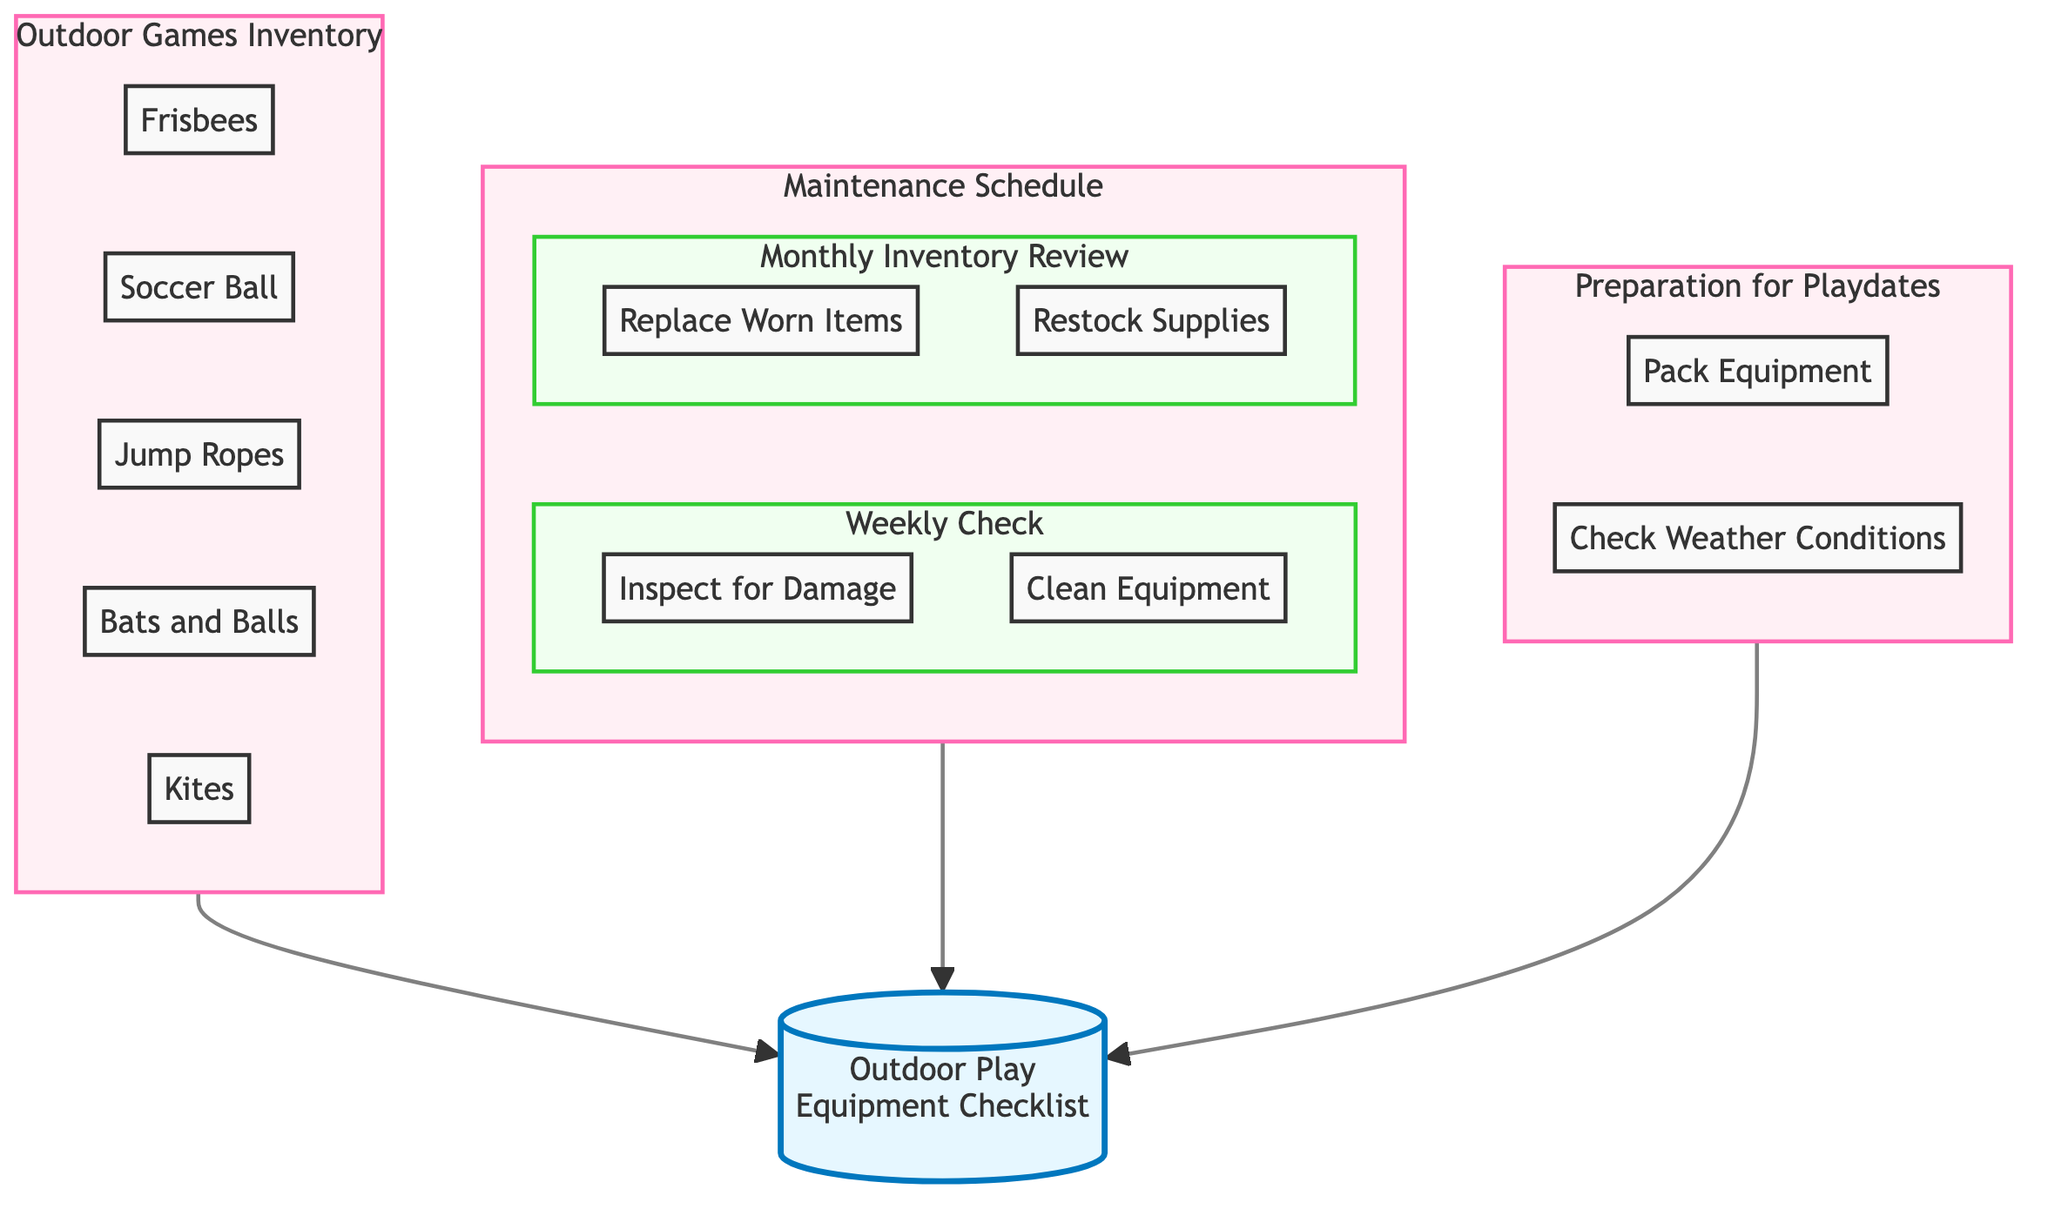What are the elements included in the Outdoor Games Inventory? The diagram shows five elements listed under the Outdoor Games Inventory: Frisbees, Soccer Ball, Jump Ropes, Bats and Balls, and Kites.
Answer: Frisbees, Soccer Ball, Jump Ropes, Bats and Balls, Kites How many items are scheduled for weekly maintenance checks? In the diagram, under the maintenance schedule, there are two tasks listed for weekly checks: Inspect for Damage and Clean Equipment, which makes a total of two items for this schedule.
Answer: 2 What maintenance task is included in the Monthly Inventory Review? Under the Monthly Inventory Review section of the maintenance schedule, there are two tasks: Replace Worn Items and Restock Supplies. Hence, the maintenance task included is identified as a process of replacing worn items.
Answer: Replace Worn Items Which section of the diagram includes "Pack Equipment"? The "Pack Equipment" task is located under the Preparation for Playdates section, which is part of the overall flow. It is linked directly to the preparation.
Answer: Preparation for Playdates How many total sections are there in the diagram? The diagram contains three main sections: Outdoor Games Inventory, Maintenance Schedule, and Preparation for Playdates. This means there are three distinct sections altogether.
Answer: 3 Which two tasks are performed weekly according to the Maintenance Schedule? Within the Weekly Check segment of the Maintenance Schedule, the tasks listed are Inspect for Damage and Clean Equipment. By identifying these tasks, it confirms there are two main activities performed weekly.
Answer: Inspect for Damage, Clean Equipment What is the relationship between "Preparation for Playdates" and the overall checklist? The "Preparation for Playdates" section is directly connected to the flow that leads to the main checklist titled "Outdoor Play Equipment Checklist". This indicates that it is a contributing step towards finalizing the checklist.
Answer: Contributing step Which task comes before "Restock Supplies"? In the Maintenance Schedule under Monthly Inventory Review, the task that comes before "Restock Supplies" is "Replace Worn Items". This order indicates a sequential process in the monthly maintenance workflow.
Answer: Replace Worn Items 